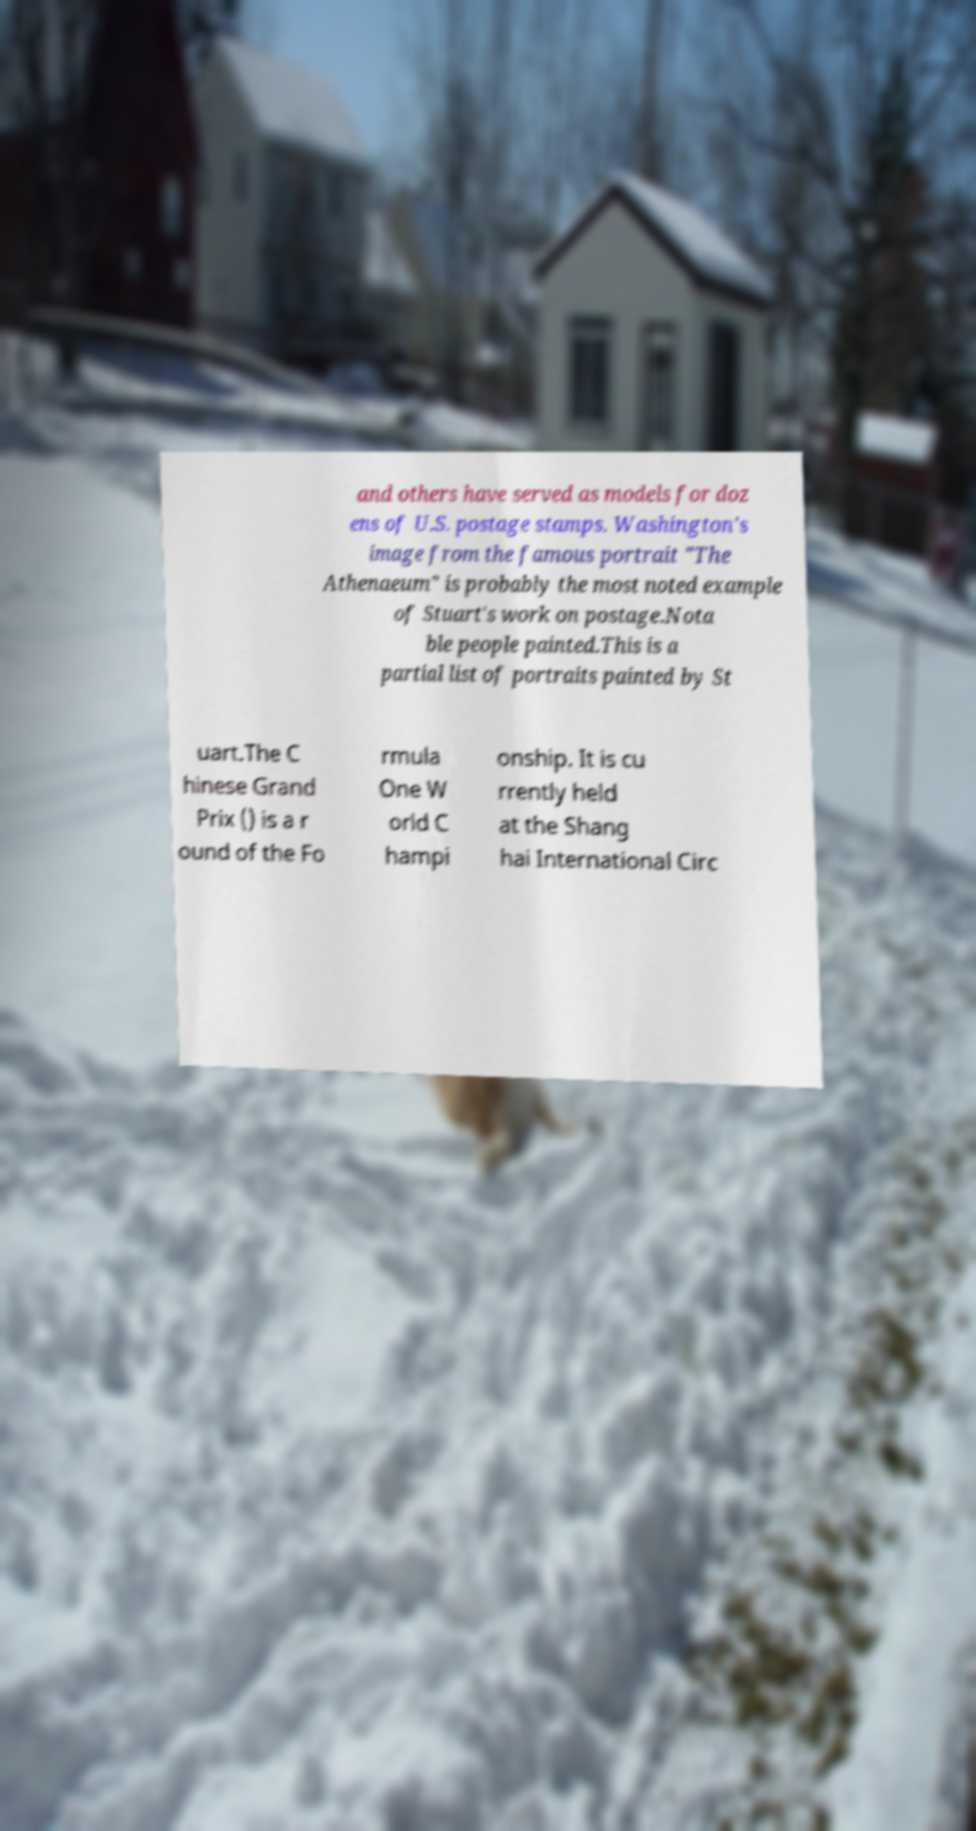Please identify and transcribe the text found in this image. and others have served as models for doz ens of U.S. postage stamps. Washington's image from the famous portrait "The Athenaeum" is probably the most noted example of Stuart's work on postage.Nota ble people painted.This is a partial list of portraits painted by St uart.The C hinese Grand Prix () is a r ound of the Fo rmula One W orld C hampi onship. It is cu rrently held at the Shang hai International Circ 